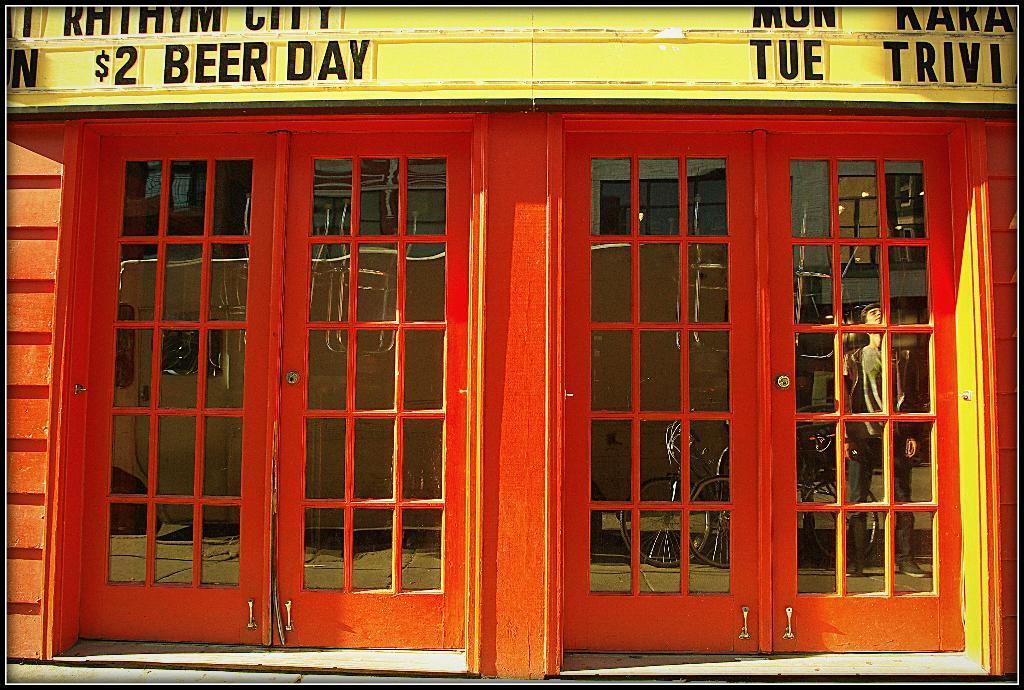Please provide a concise description of this image. In this image I can see a building which is in red ,yellow color. I can see reflection of the person and bicycle on the glass door. 